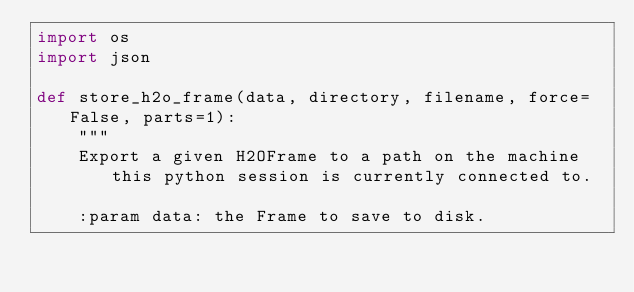<code> <loc_0><loc_0><loc_500><loc_500><_Python_>import os
import json

def store_h2o_frame(data, directory, filename, force=False, parts=1):
    """
    Export a given H2OFrame to a path on the machine this python session is currently connected to.

    :param data: the Frame to save to disk.</code> 